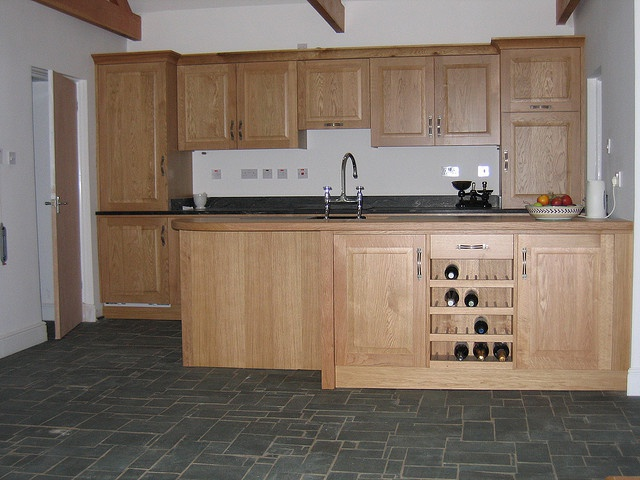Describe the objects in this image and their specific colors. I can see bowl in gray, darkgray, tan, and lightgray tones, bottle in gray, black, and maroon tones, bottle in gray, black, and maroon tones, bottle in gray and black tones, and bottle in gray, black, and darkgray tones in this image. 